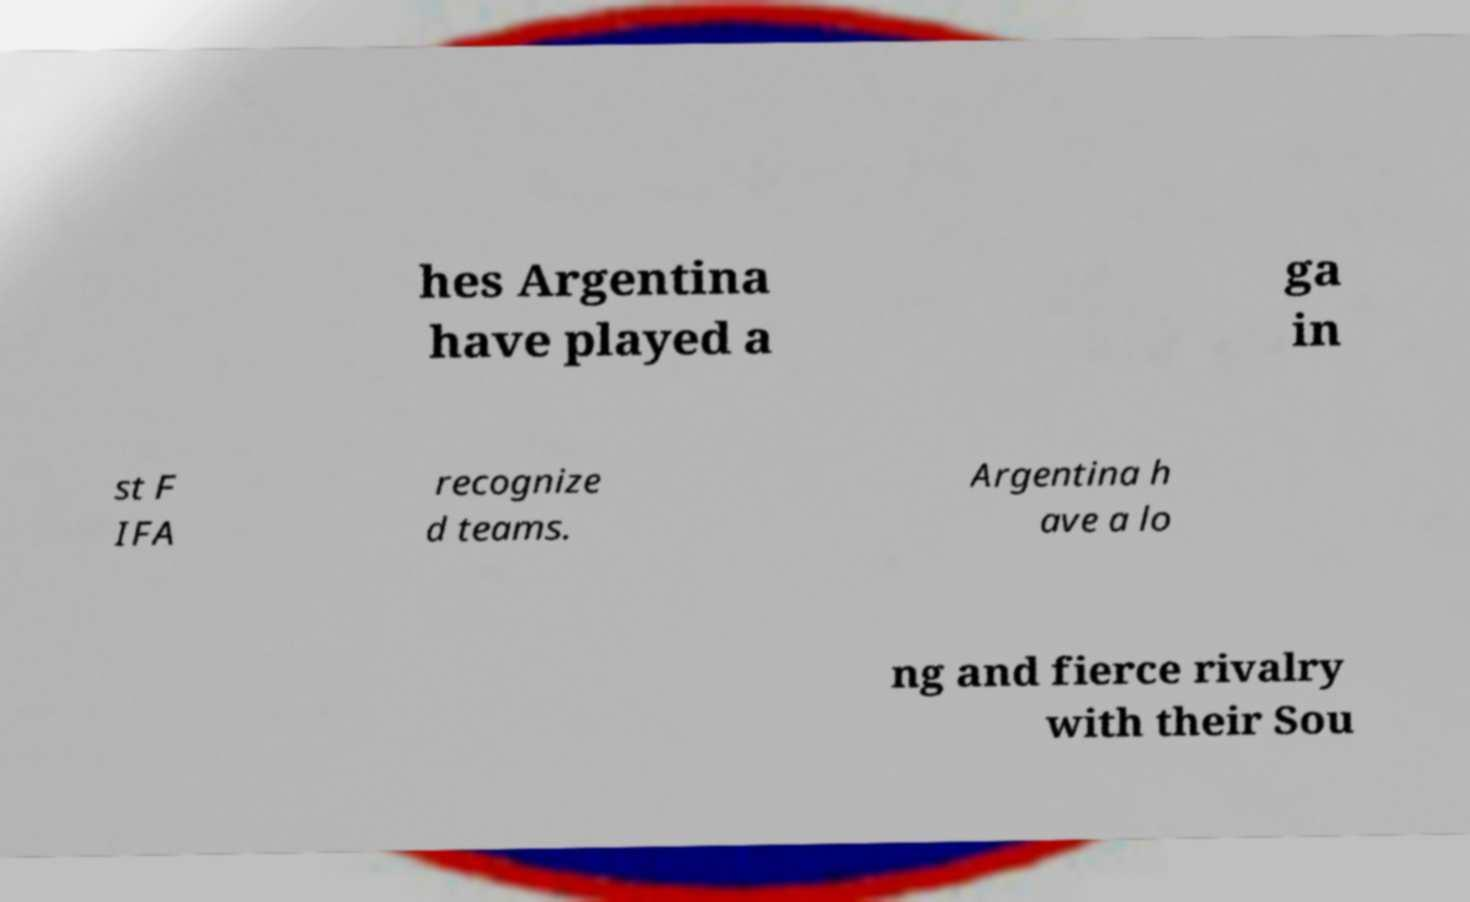Can you accurately transcribe the text from the provided image for me? hes Argentina have played a ga in st F IFA recognize d teams. Argentina h ave a lo ng and fierce rivalry with their Sou 